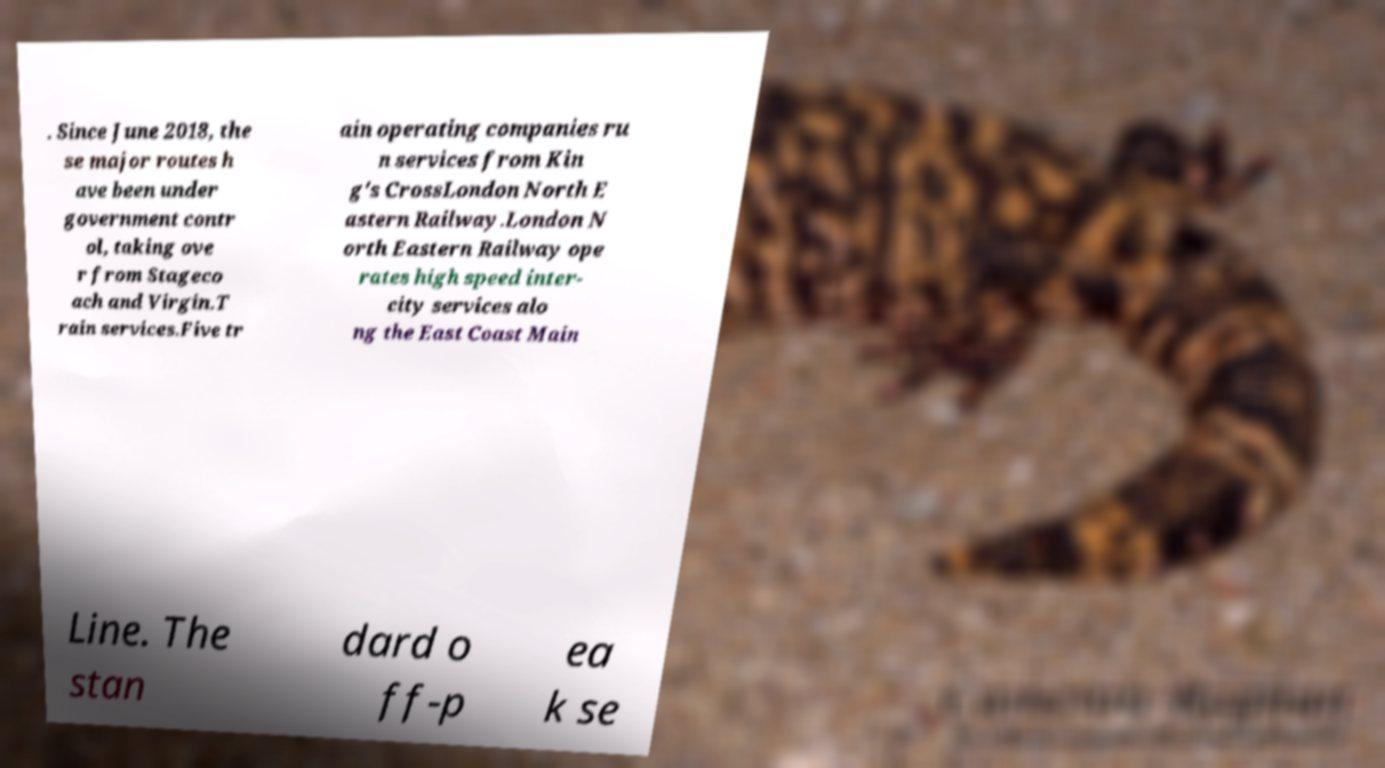For documentation purposes, I need the text within this image transcribed. Could you provide that? . Since June 2018, the se major routes h ave been under government contr ol, taking ove r from Stageco ach and Virgin.T rain services.Five tr ain operating companies ru n services from Kin g's CrossLondon North E astern Railway.London N orth Eastern Railway ope rates high speed inter- city services alo ng the East Coast Main Line. The stan dard o ff-p ea k se 